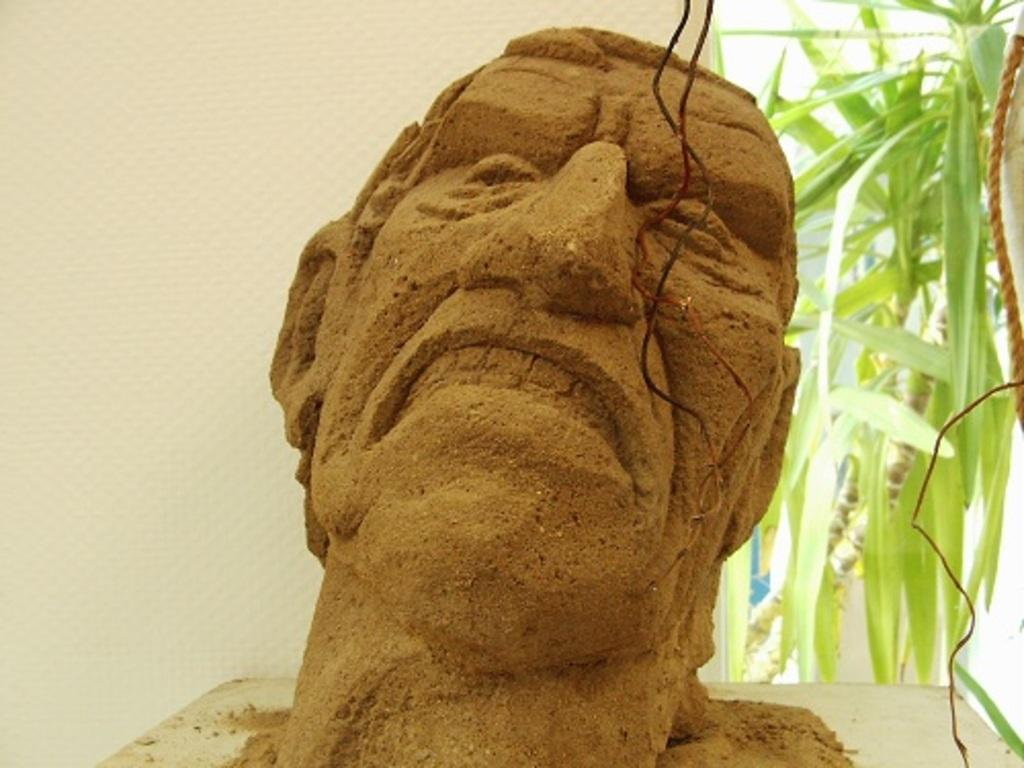What is the main subject of the image? The main subject of the image is a person's face made up of sand on a board. What can be seen in the background of the image? A: In the background of the image, there is a wall, a rope, and a plant. What type of cork can be seen floating in the sand face in the image? There is no cork present in the image, as the main subject is a sand face and not a liquid environment. 